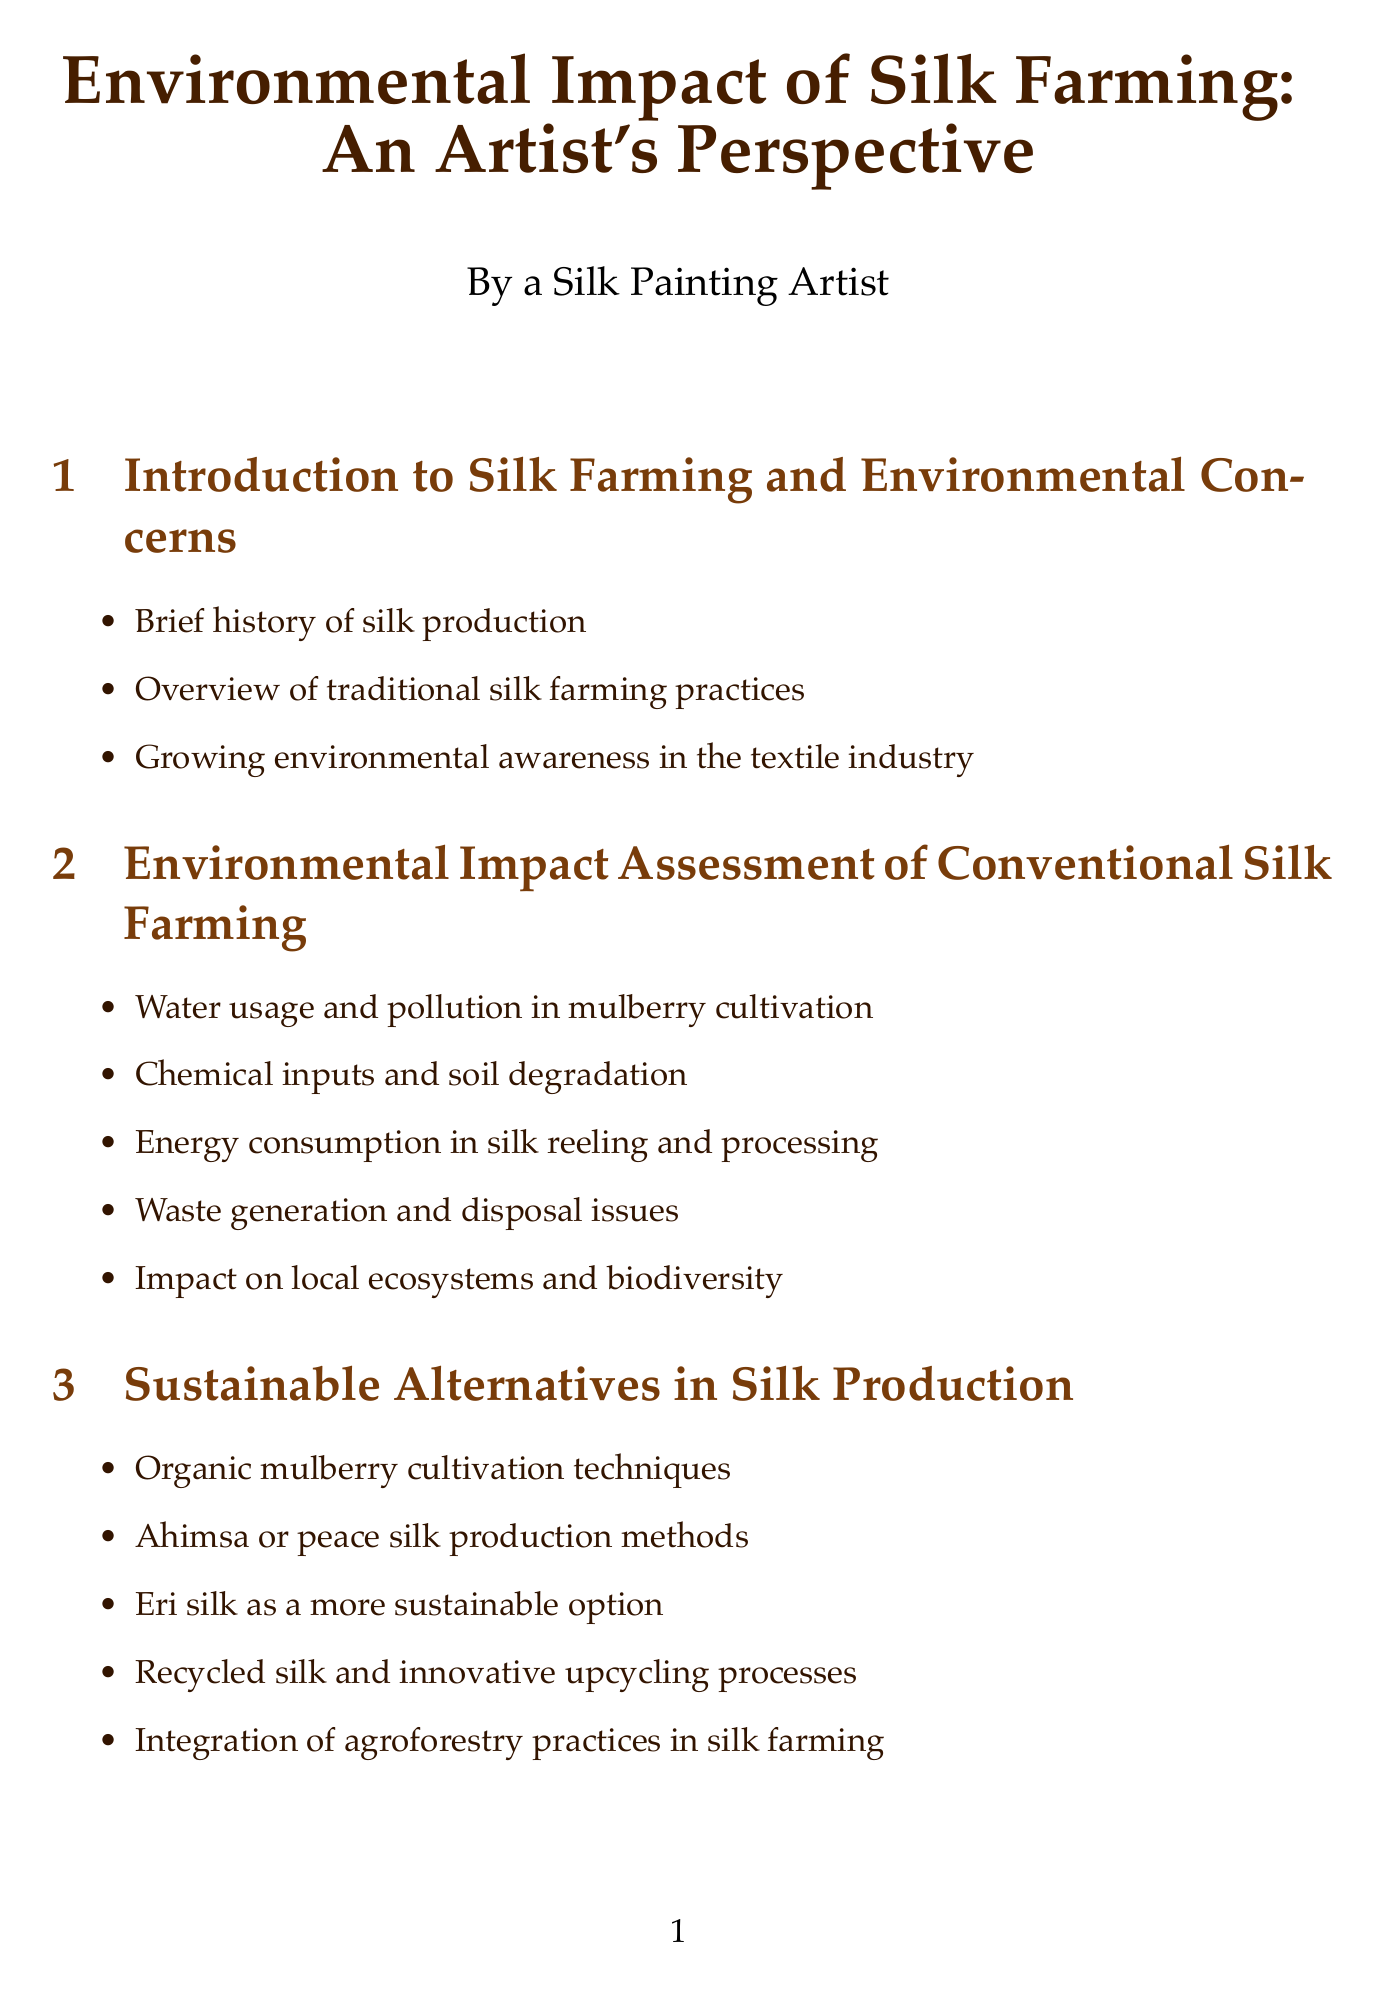What is the water consumption for silk production? Water consumption is specified as 1,500 liters per kg of raw silk produced in the key statistics section.
Answer: 1,500 liters What is the focus of the Centre for Sustainable Fashion? The document mentions that the Centre for Sustainable Fashion focuses on research and education on sustainable fashion practices.
Answer: Research and education on sustainable fashion practices Which sustainable silk brand is listed first? The sustainable silk brands section lists Cocccon as the first brand.
Answer: Cocccon What are the natural sources of eco-friendly dyes mentioned? The section on eco-friendly dyes lists natural sources such as plants and insects, including Indigofera tinctoria for indigo and Rubia tinctorum for madder red.
Answer: Indigofera tinctoria, Rubia tinctorum What is the energy consumption for silk yarn production? The document includes a statistic stating that energy consumption is 132 kWh per kg of silk yarn produced.
Answer: 132 kWh Which section discusses the impact on local ecosystems? The environmental impact assessment section discusses the impact of conventional silk farming on local ecosystems and biodiversity.
Answer: Environmental Impact Assessment of Conventional Silk Farming How many case studies of sustainable silk initiatives are provided? The document presents three case studies of sustainable silk initiatives under a dedicated section.
Answer: Three What is the CO2 emissions figure per meter of silk fabric? According to the key statistics provided, CO2 emissions are 12 kg per meter of silk fabric.
Answer: 12 kg 